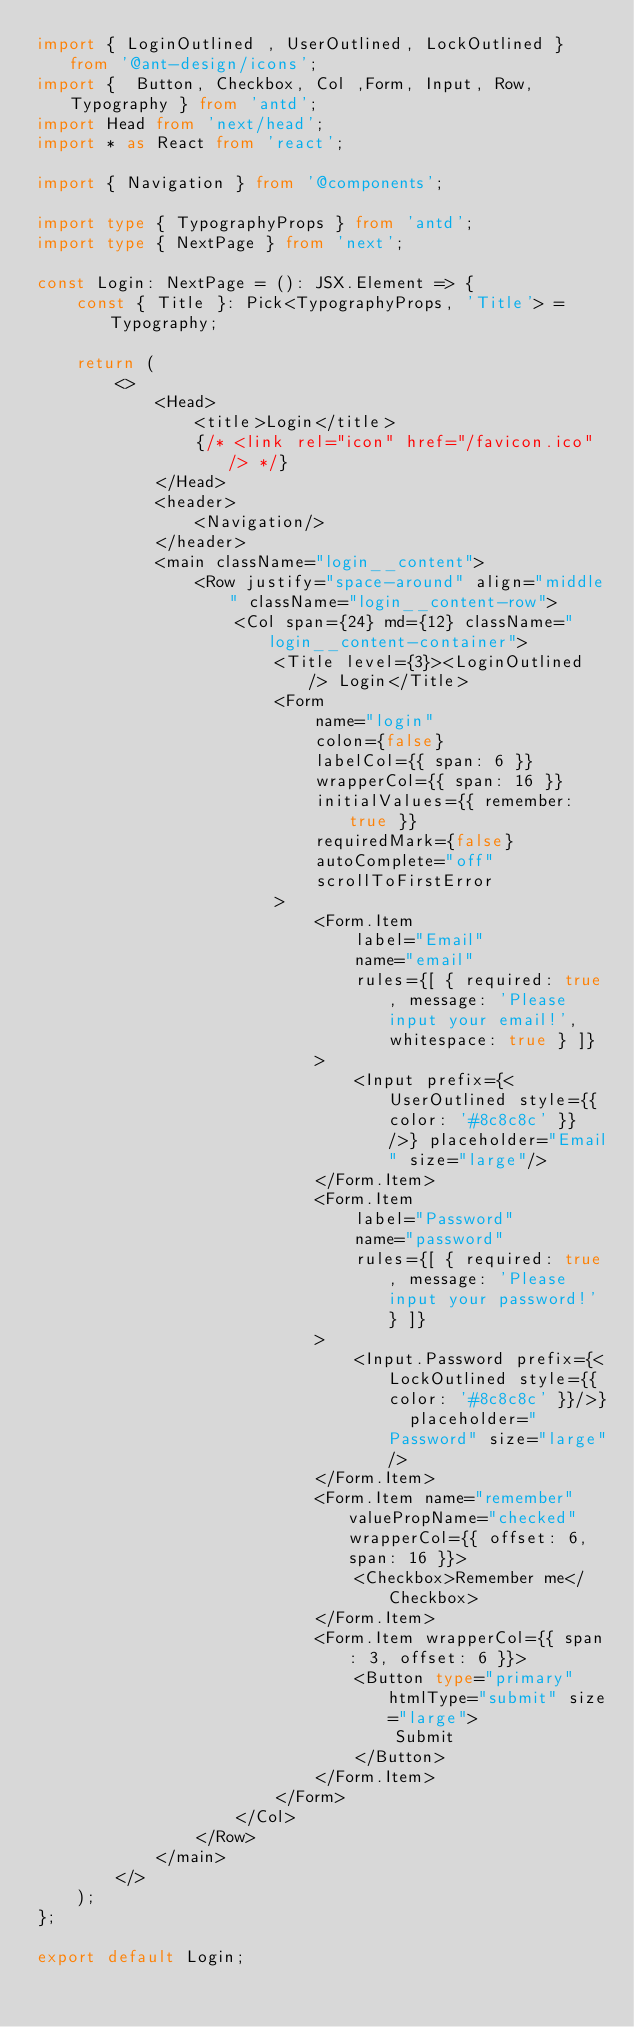<code> <loc_0><loc_0><loc_500><loc_500><_TypeScript_>import { LoginOutlined , UserOutlined, LockOutlined } from '@ant-design/icons';
import {  Button, Checkbox, Col ,Form, Input, Row, Typography } from 'antd';
import Head from 'next/head';
import * as React from 'react';

import { Navigation } from '@components';

import type { TypographyProps } from 'antd';
import type { NextPage } from 'next';

const Login: NextPage = (): JSX.Element => {
	const { Title }: Pick<TypographyProps, 'Title'> = Typography;

	return (
		<>
			<Head>
				<title>Login</title>
				{/* <link rel="icon" href="/favicon.ico" /> */}
			</Head>
			<header>
				<Navigation/>
			</header>
			<main className="login__content">
				<Row justify="space-around" align="middle" className="login__content-row">
					<Col span={24} md={12} className="login__content-container">
						<Title level={3}><LoginOutlined /> Login</Title>
						<Form
							name="login"
							colon={false}
							labelCol={{ span: 6 }}
							wrapperCol={{ span: 16 }}
							initialValues={{ remember: true }}
							requiredMark={false}
							autoComplete="off"
							scrollToFirstError
						>
							<Form.Item
								label="Email"
								name="email"
								rules={[ { required: true, message: 'Please input your email!', whitespace: true } ]}
							>
								<Input prefix={<UserOutlined style={{ color: '#8c8c8c' }} />} placeholder="Email" size="large"/>
							</Form.Item>
							<Form.Item
								label="Password"
								name="password"
								rules={[ { required: true, message: 'Please input your password!' } ]}
							>
								<Input.Password prefix={<LockOutlined style={{ color: '#8c8c8c' }}/>}  placeholder="Password" size="large"/>
							</Form.Item>
							<Form.Item name="remember" valuePropName="checked" wrapperCol={{ offset: 6, span: 16 }}>
								<Checkbox>Remember me</Checkbox>
							</Form.Item>
							<Form.Item wrapperCol={{ span: 3, offset: 6 }}>
								<Button type="primary" htmlType="submit" size="large">
          							Submit
								</Button>
							</Form.Item>
						</Form>
					</Col>
				</Row>
			</main>
		</>
	);
};

export default Login;</code> 